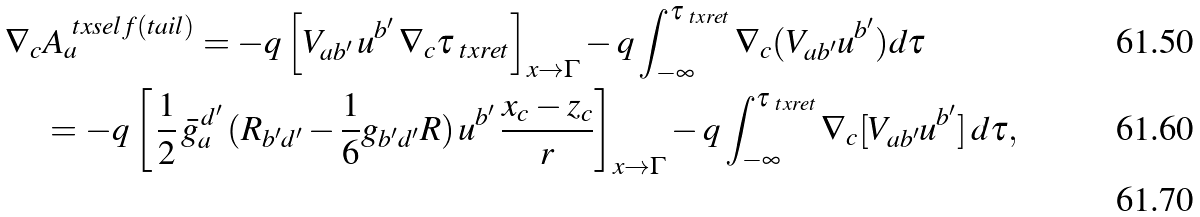Convert formula to latex. <formula><loc_0><loc_0><loc_500><loc_500>\nabla _ { c } & A _ { a } ^ { \ t x { s e l f ( t a i l ) } } = - q \left [ V _ { a b ^ { \prime } } \, u ^ { b ^ { \prime } } \, \nabla _ { c } \tau _ { \ t x { r e t } } \right ] _ { x \to \Gamma } - q \int _ { - \infty } ^ { \tau _ { \ t x { r e t } } } \nabla _ { c } ( V _ { a b ^ { \prime } } u ^ { b ^ { \prime } } ) d \tau \\ & = - q \left [ \, \frac { 1 } { 2 } \, \bar { g } _ { a } ^ { \, d ^ { \prime } } \, ( R _ { b ^ { \prime } d ^ { \prime } } - \frac { 1 } { 6 } g _ { b ^ { \prime } d ^ { \prime } } R ) \, u ^ { b ^ { \prime } } \, \frac { x _ { c } - z _ { c } } { r } \right ] _ { x \to \Gamma } - q \int _ { - \infty } ^ { \tau _ { \ t x { r e t } } } \nabla _ { c } [ V _ { a b ^ { \prime } } u ^ { b ^ { \prime } } ] \, d \tau , \\</formula> 